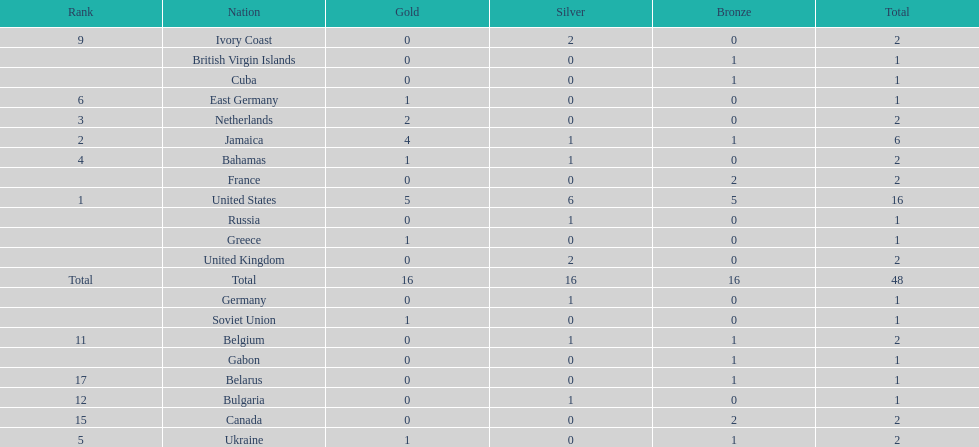How many nations won more than one silver medal? 3. 